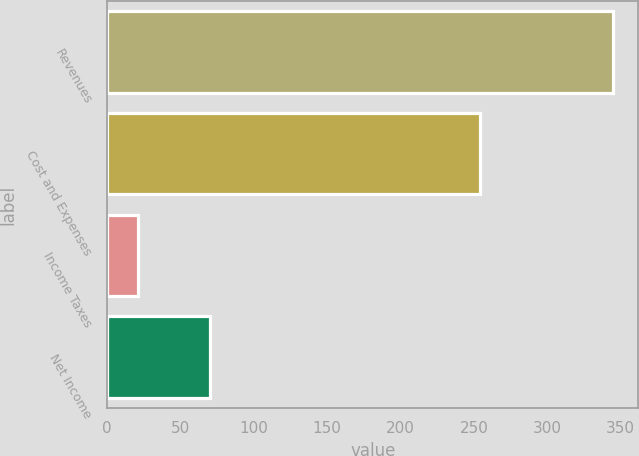Convert chart to OTSL. <chart><loc_0><loc_0><loc_500><loc_500><bar_chart><fcel>Revenues<fcel>Cost and Expenses<fcel>Income Taxes<fcel>Net Income<nl><fcel>345<fcel>254<fcel>21<fcel>70<nl></chart> 